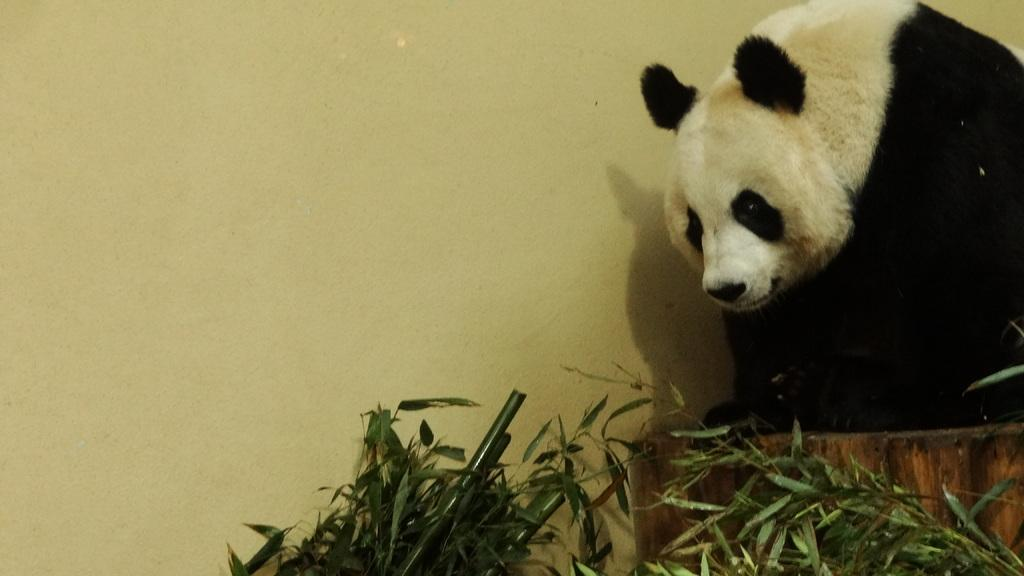What animal is located on the right side of the image? There is a panda on the right side of the image. What type of vegetation can be seen at the bottom of the image? There are plants visible at the bottom of the image. What is visible in the background of the image? There is a wall in the background of the image. What type of advertisement can be seen on the panda's back in the image? There is no advertisement visible on the panda's back in the image. What type of flowers are growing near the panda in the image? There are no flowers mentioned or visible in the image; only plants are mentioned. 